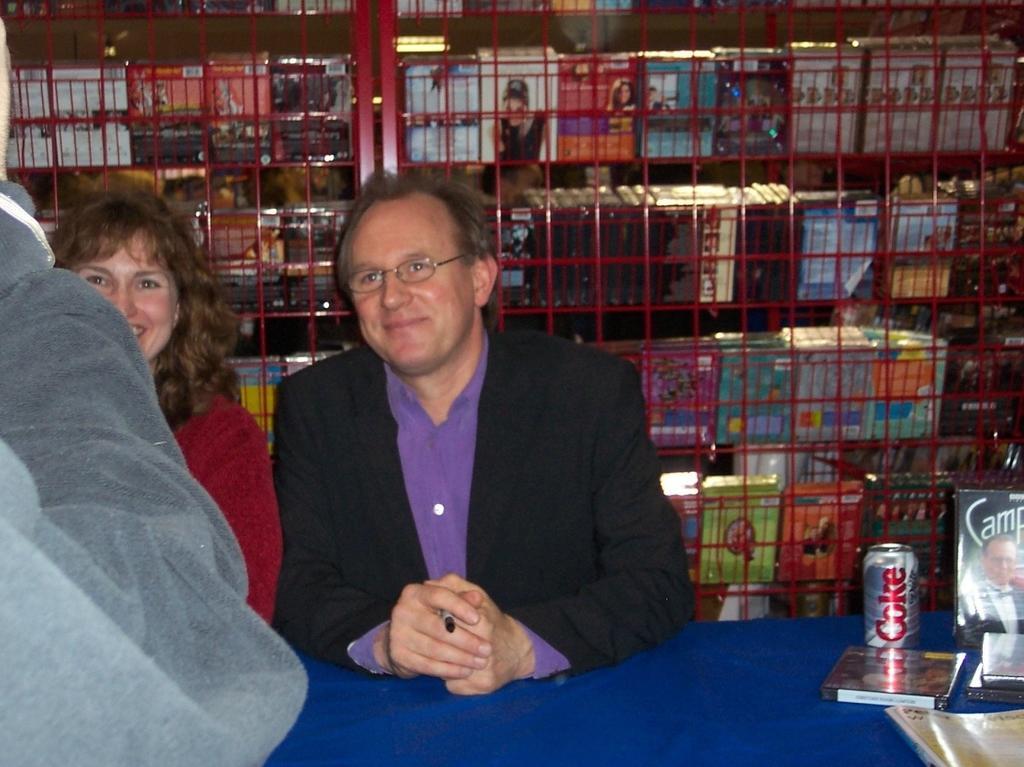Can you describe this image briefly? In this image in the front there is a person and there is a table which is covered with a blue colour cloth. On the table there is a tin and there are cassettes cover with some text and images on it and there is a book. In the center there are persons sitting and smiling and in the background there is stand which is red in colour and on the stand there are boxes. 